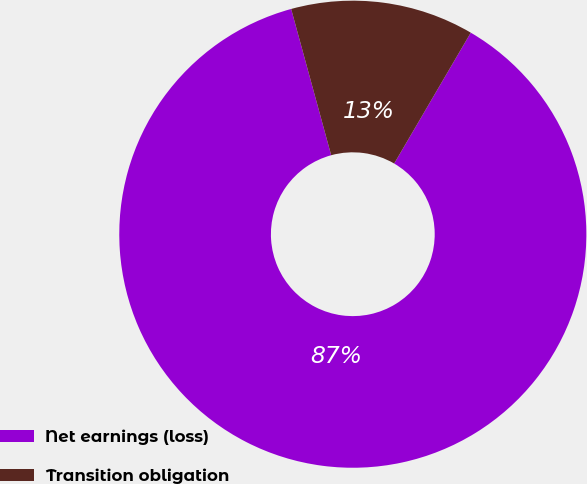Convert chart. <chart><loc_0><loc_0><loc_500><loc_500><pie_chart><fcel>Net earnings (loss)<fcel>Transition obligation<nl><fcel>87.32%<fcel>12.68%<nl></chart> 